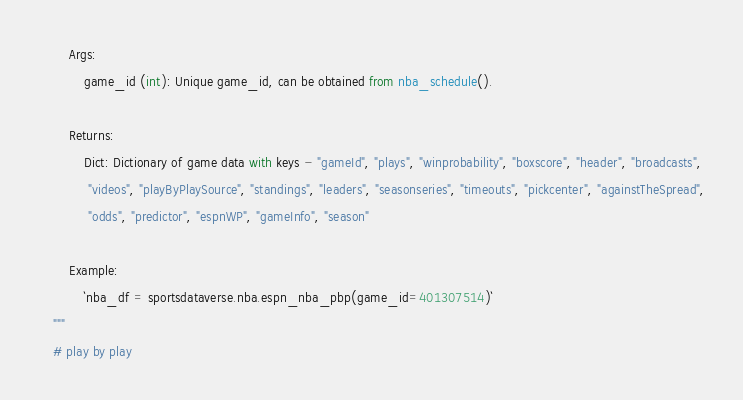<code> <loc_0><loc_0><loc_500><loc_500><_Python_>        Args:
            game_id (int): Unique game_id, can be obtained from nba_schedule().

        Returns:
            Dict: Dictionary of game data with keys - "gameId", "plays", "winprobability", "boxscore", "header", "broadcasts",
             "videos", "playByPlaySource", "standings", "leaders", "seasonseries", "timeouts", "pickcenter", "againstTheSpread",
             "odds", "predictor", "espnWP", "gameInfo", "season"

        Example:
            `nba_df = sportsdataverse.nba.espn_nba_pbp(game_id=401307514)`
    """
    # play by play</code> 